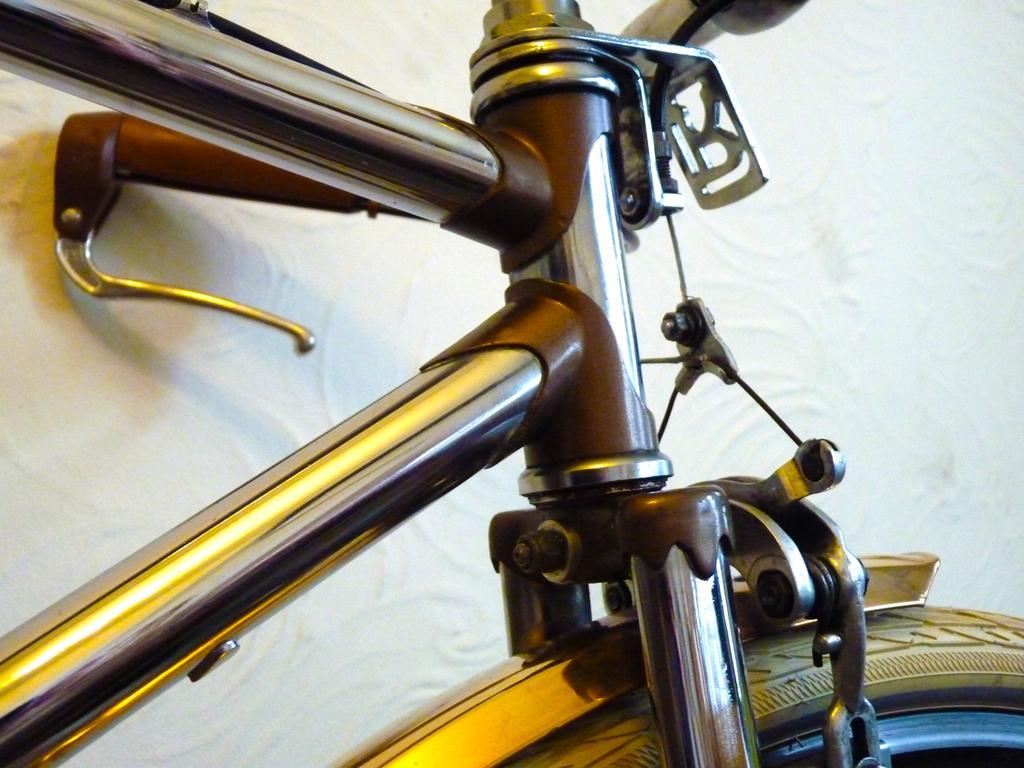How would you summarize this image in a sentence or two? In this image in the foreground there is one cycle, and in the background there is a wall. 